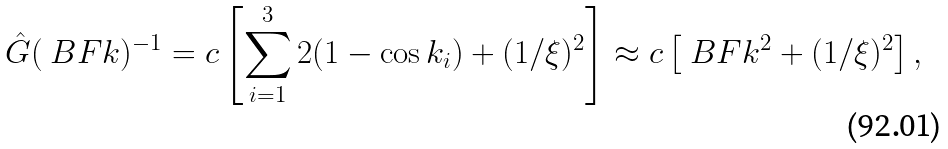<formula> <loc_0><loc_0><loc_500><loc_500>\hat { G } ( \ B F { k } ) ^ { - 1 } = c \left [ \sum _ { i = 1 } ^ { 3 } 2 ( 1 - \cos k _ { i } ) + ( 1 / \xi ) ^ { 2 } \right ] \approx c \left [ \ B F { k } ^ { 2 } + ( 1 / \xi ) ^ { 2 } \right ] ,</formula> 